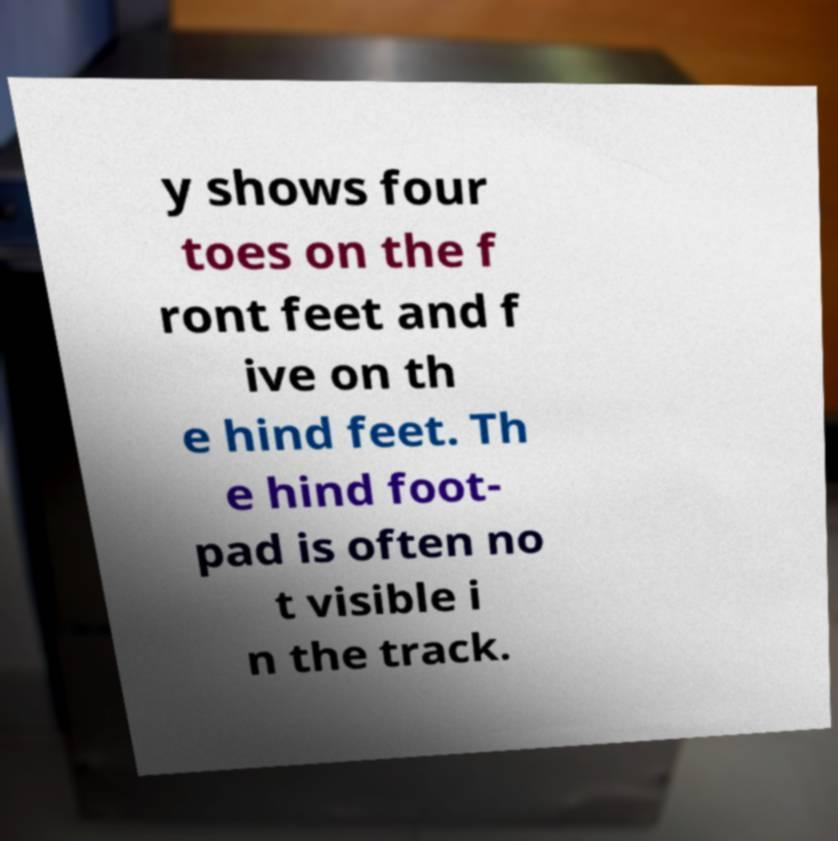Could you assist in decoding the text presented in this image and type it out clearly? y shows four toes on the f ront feet and f ive on th e hind feet. Th e hind foot- pad is often no t visible i n the track. 